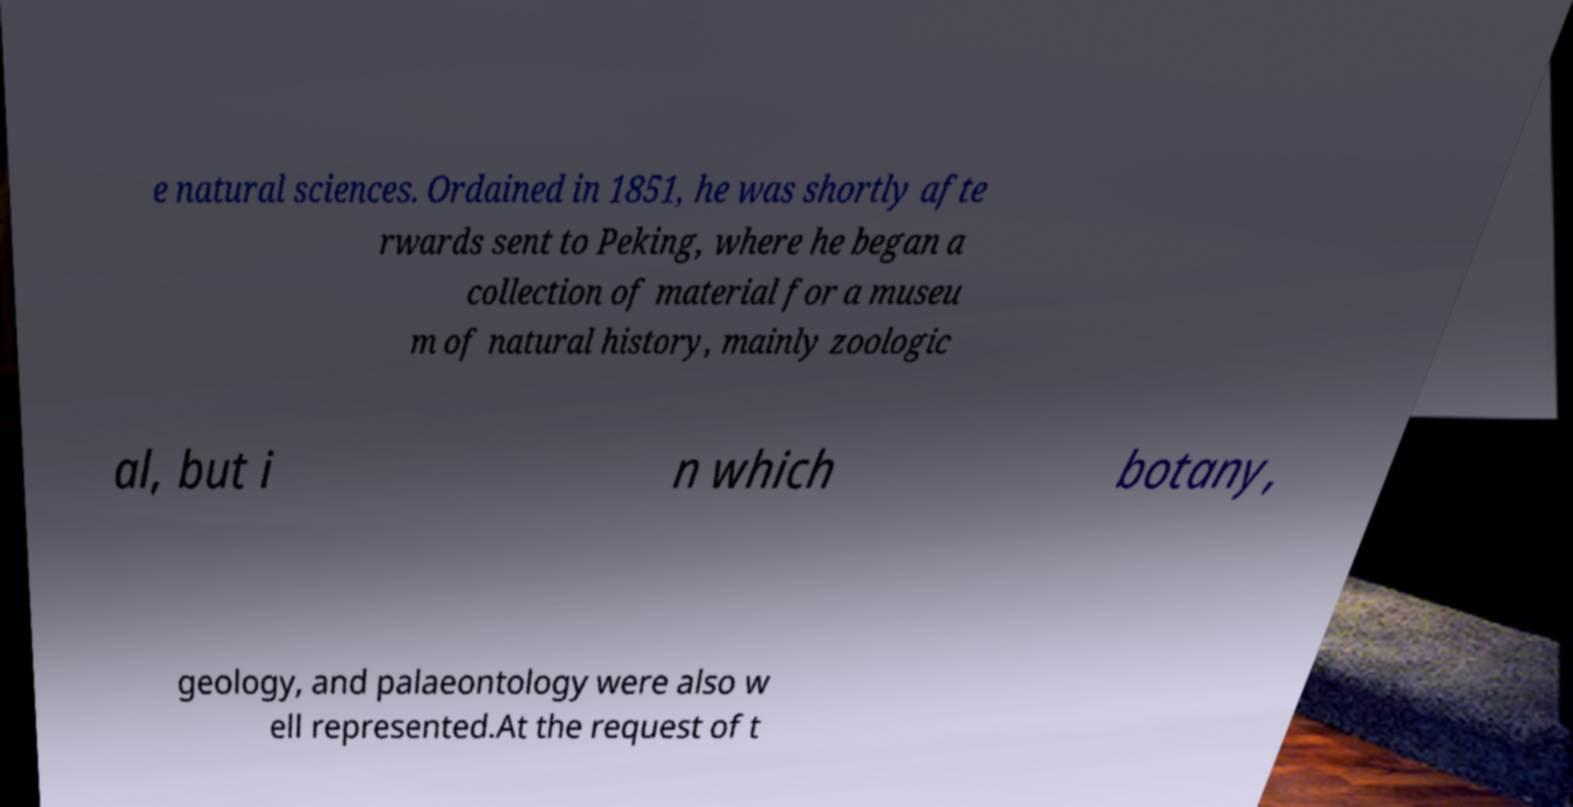I need the written content from this picture converted into text. Can you do that? e natural sciences. Ordained in 1851, he was shortly afte rwards sent to Peking, where he began a collection of material for a museu m of natural history, mainly zoologic al, but i n which botany, geology, and palaeontology were also w ell represented.At the request of t 